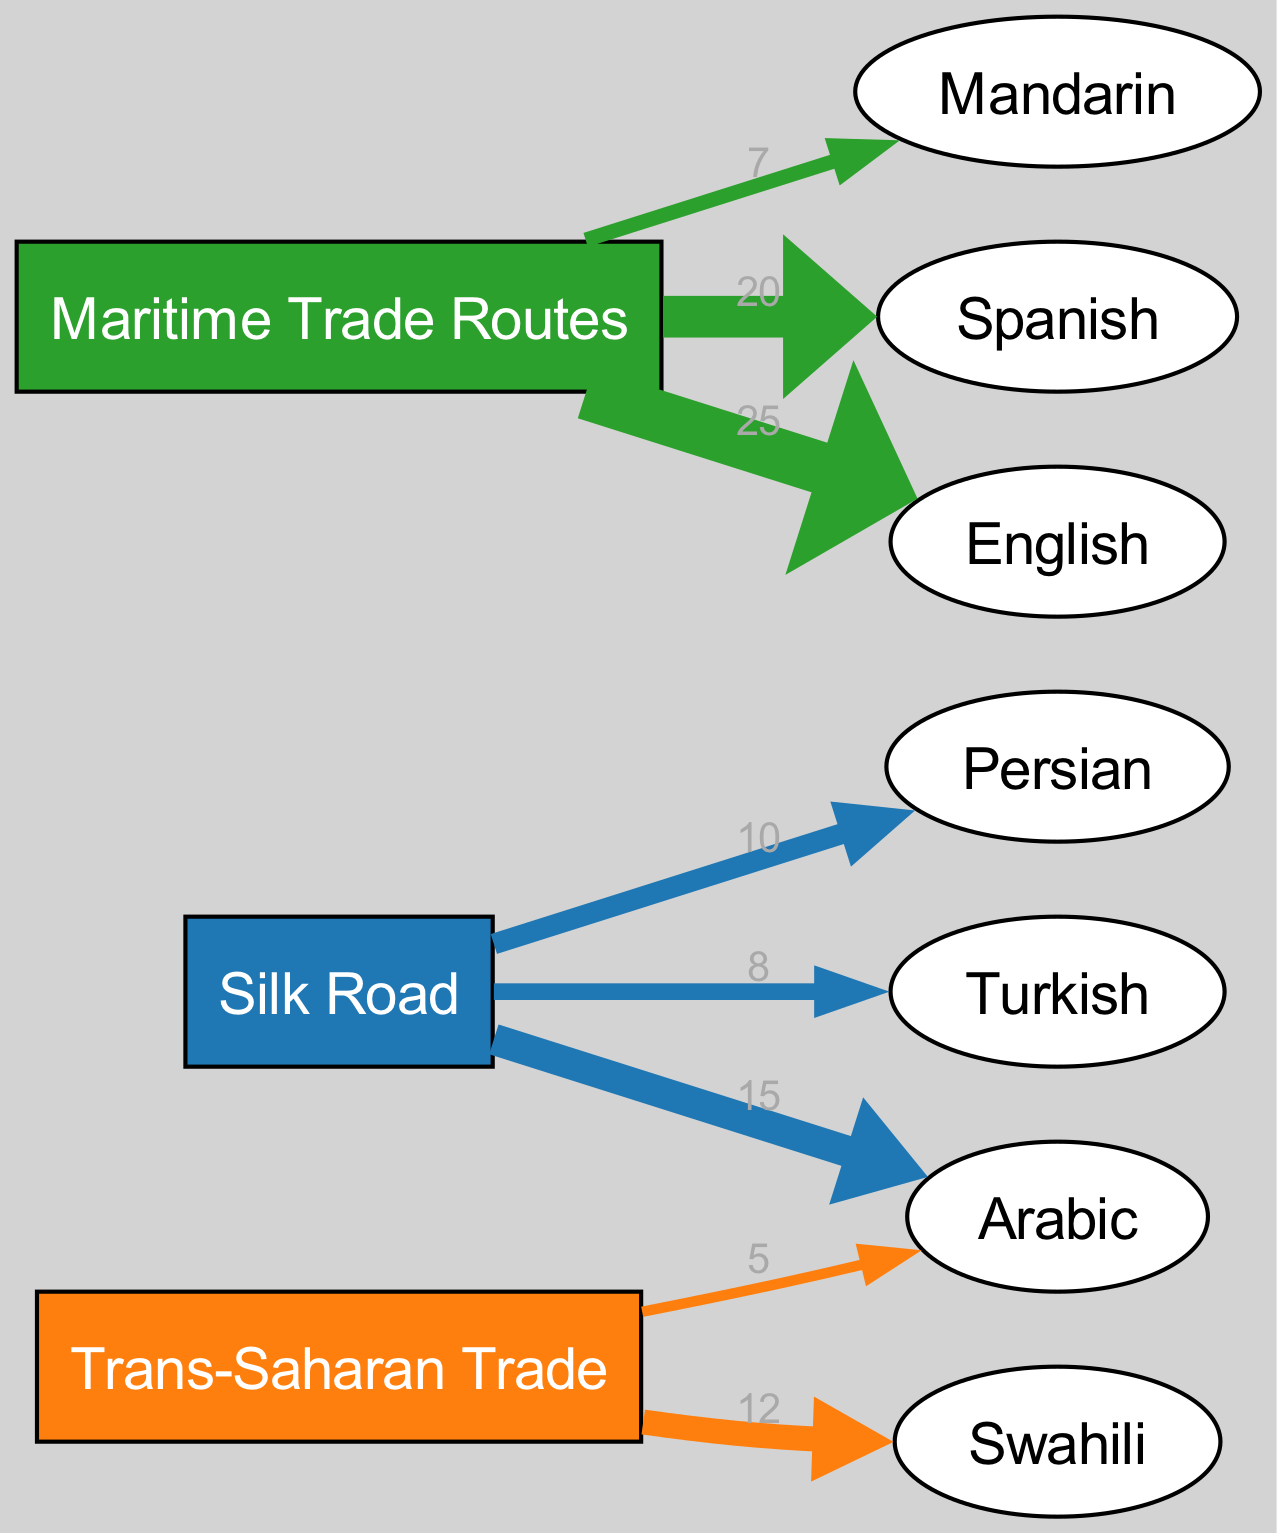What is the total number of nodes in the diagram? The diagram contains 10 distinct nodes, which are the three trade routes and seven languages.
Answer: 10 Which language has the highest value of vocabulary adoption through Maritime Trade Routes? Observing the flow, English has the highest value of 25 from the Maritime Trade Routes, indicating strong influence.
Answer: English How many languages are influenced by the Silk Road? The Silk Road directs influence to three languages: Arabic, Persian, and Turkish, so the count is three.
Answer: 3 What term has the lowest value flowing from Trans-Saharan Trade? By checking the values, Arabic has the lowest value of 5 that flows from the Trans-Saharan Trade.
Answer: Arabic What is the total vocabulary adopted from the Maritime Trade Routes? The values from the Maritime Trade Routes are added: 20 (Spanish) + 25 (English) + 7 (Mandarin) = 52.
Answer: 52 Which trade route influences Swahili? The flow clearly indicates that Swahili is influenced solely by the Trans-Saharan Trade route.
Answer: Trans-Saharan Trade What is the value associated with Persian from the Silk Road? The flow from the Silk Road to Persian shows a value of 10, indicating the influence level.
Answer: 10 How many connections does Mandarin have to trade routes? The diagram shows one connection from Maritime Trade Routes leading to Mandarin, indicating a single influence.
Answer: 1 What is the relationship between Maritime Trade Routes and Spanish? The diagram shows that there is a direct connection from Maritime Trade Routes to Spanish, with a value of 20, indicating vocabulary adoption.
Answer: Direct connection 